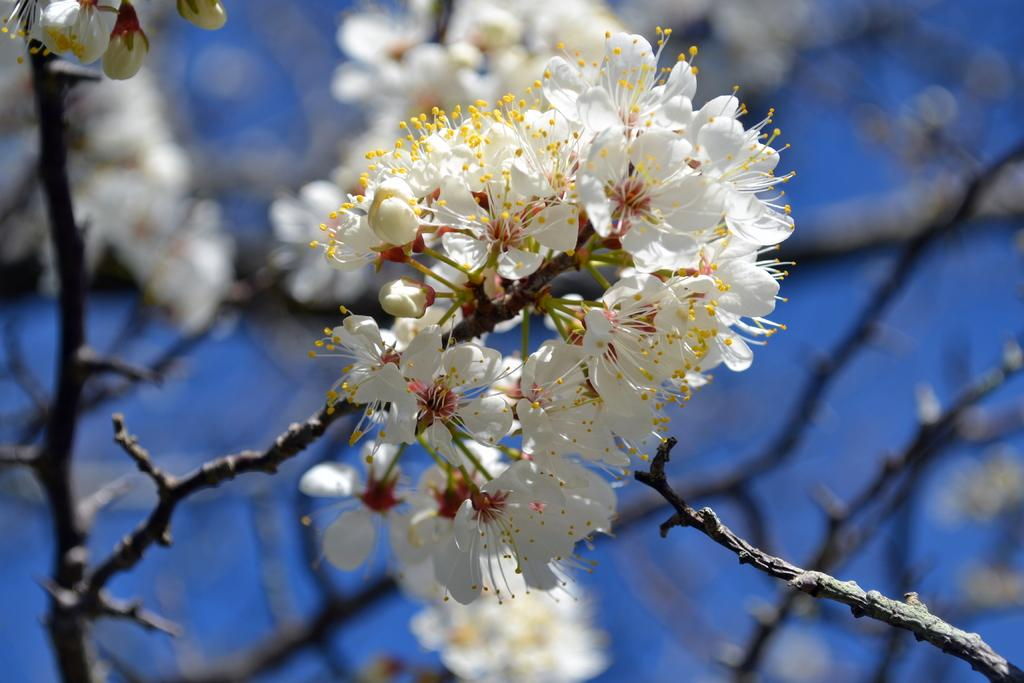What type of flowers can be seen in the image? There are beautiful white flowers in the image. Where are the flowers located? The flowers are on the branch of a tree. What type of pies are being suggested for the flowers in the image? There is no mention of pies or any suggestion related to the flowers in the image. 